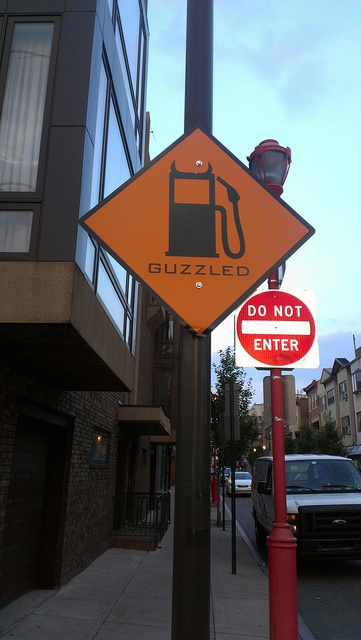Describe the objects in this image and their specific colors. I can see truck in darkblue, black, navy, blue, and darkgray tones, stop sign in darkblue, red, white, brown, and lightpink tones, car in darkblue, black, blue, gray, and darkgray tones, and car in darkblue, black, blue, gray, and navy tones in this image. 